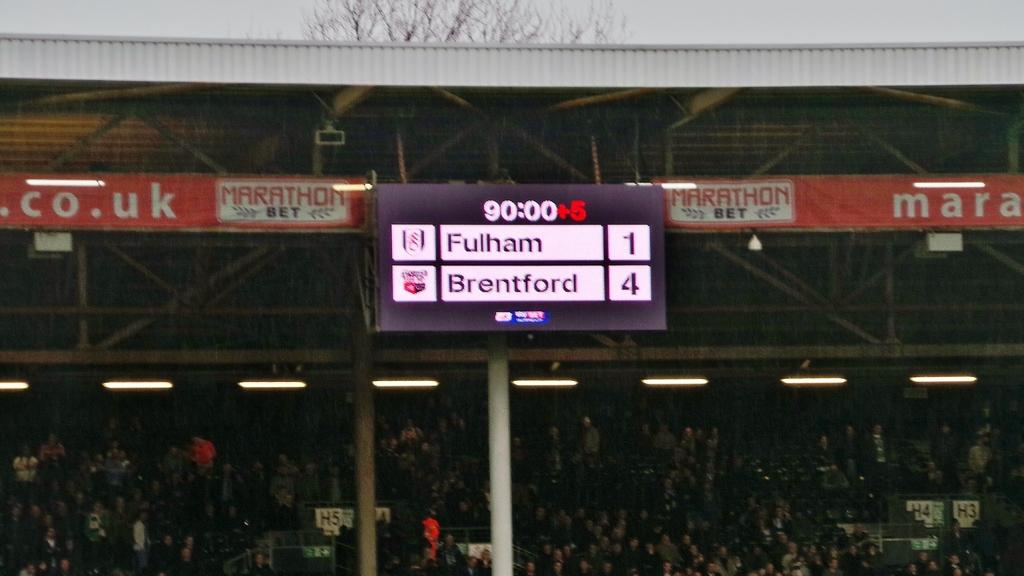<image>
Render a clear and concise summary of the photo. A score board for Fulham and Brentford with a score of 1 to 4. 